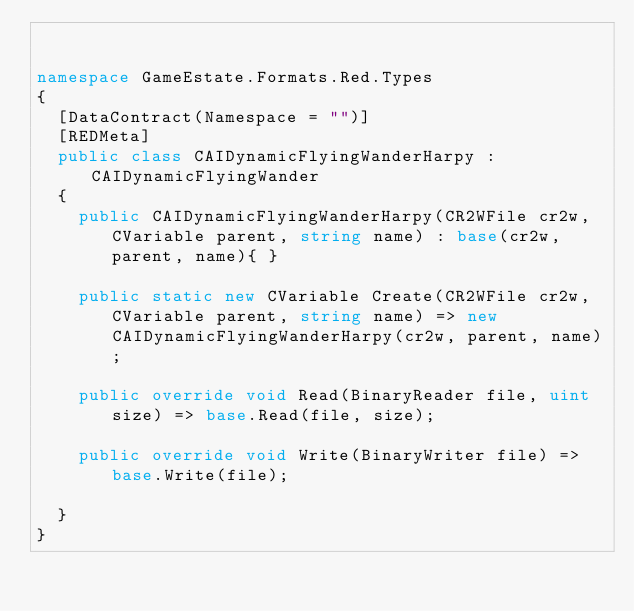Convert code to text. <code><loc_0><loc_0><loc_500><loc_500><_C#_>

namespace GameEstate.Formats.Red.Types
{
	[DataContract(Namespace = "")]
	[REDMeta]
	public class CAIDynamicFlyingWanderHarpy : CAIDynamicFlyingWander
	{
		public CAIDynamicFlyingWanderHarpy(CR2WFile cr2w, CVariable parent, string name) : base(cr2w, parent, name){ }

		public static new CVariable Create(CR2WFile cr2w, CVariable parent, string name) => new CAIDynamicFlyingWanderHarpy(cr2w, parent, name);

		public override void Read(BinaryReader file, uint size) => base.Read(file, size);

		public override void Write(BinaryWriter file) => base.Write(file);

	}
}</code> 